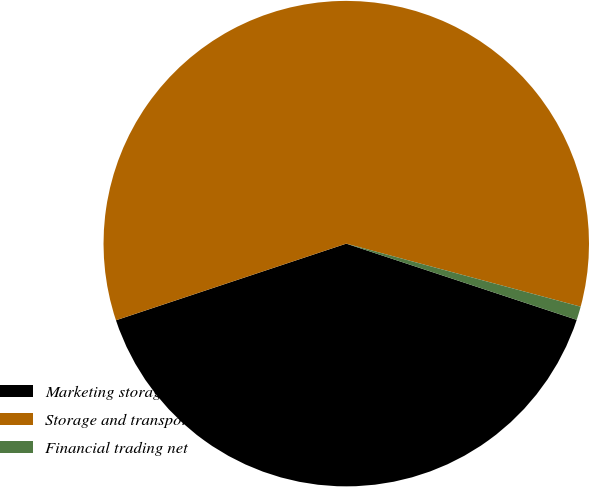Convert chart. <chart><loc_0><loc_0><loc_500><loc_500><pie_chart><fcel>Marketing storage and<fcel>Storage and transportation<fcel>Financial trading net<nl><fcel>39.8%<fcel>59.29%<fcel>0.9%<nl></chart> 